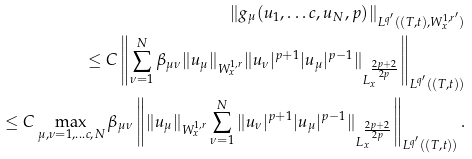Convert formula to latex. <formula><loc_0><loc_0><loc_500><loc_500>\| g _ { \mu } ( u _ { 1 } , \dots c , u _ { N } , p ) \| _ { L ^ { q ^ { \prime } } ( ( T , t ) , W ^ { 1 , r ^ { \prime } } _ { x } ) } & \\ \leq C \left \| \sum ^ { N } _ { \nu = 1 } \beta _ { \mu \nu } \| u _ { \mu } \| _ { W ^ { 1 , r } _ { x } } \| u _ { \nu } | ^ { p + 1 } | u _ { \mu } | ^ { p - 1 } \| _ { L _ { x } ^ { \frac { 2 p + 2 } { 2 p } } } \right \| _ { L ^ { q ^ { \prime } } ( ( T , t ) ) } & \\ \leq C \max _ { \mu , \nu = 1 , \dots c , N } \beta _ { \mu \nu } \left \| \| u _ { \mu } \| _ { W ^ { 1 , r } _ { x } } \sum ^ { N } _ { \nu = 1 } \| u _ { \nu } | ^ { p + 1 } | u _ { \mu } | ^ { p - 1 } \| _ { L _ { x } ^ { \frac { 2 p + 2 } { 2 p } } } \right \| _ { L ^ { q ^ { \prime } } ( ( T , t ) ) } . &</formula> 